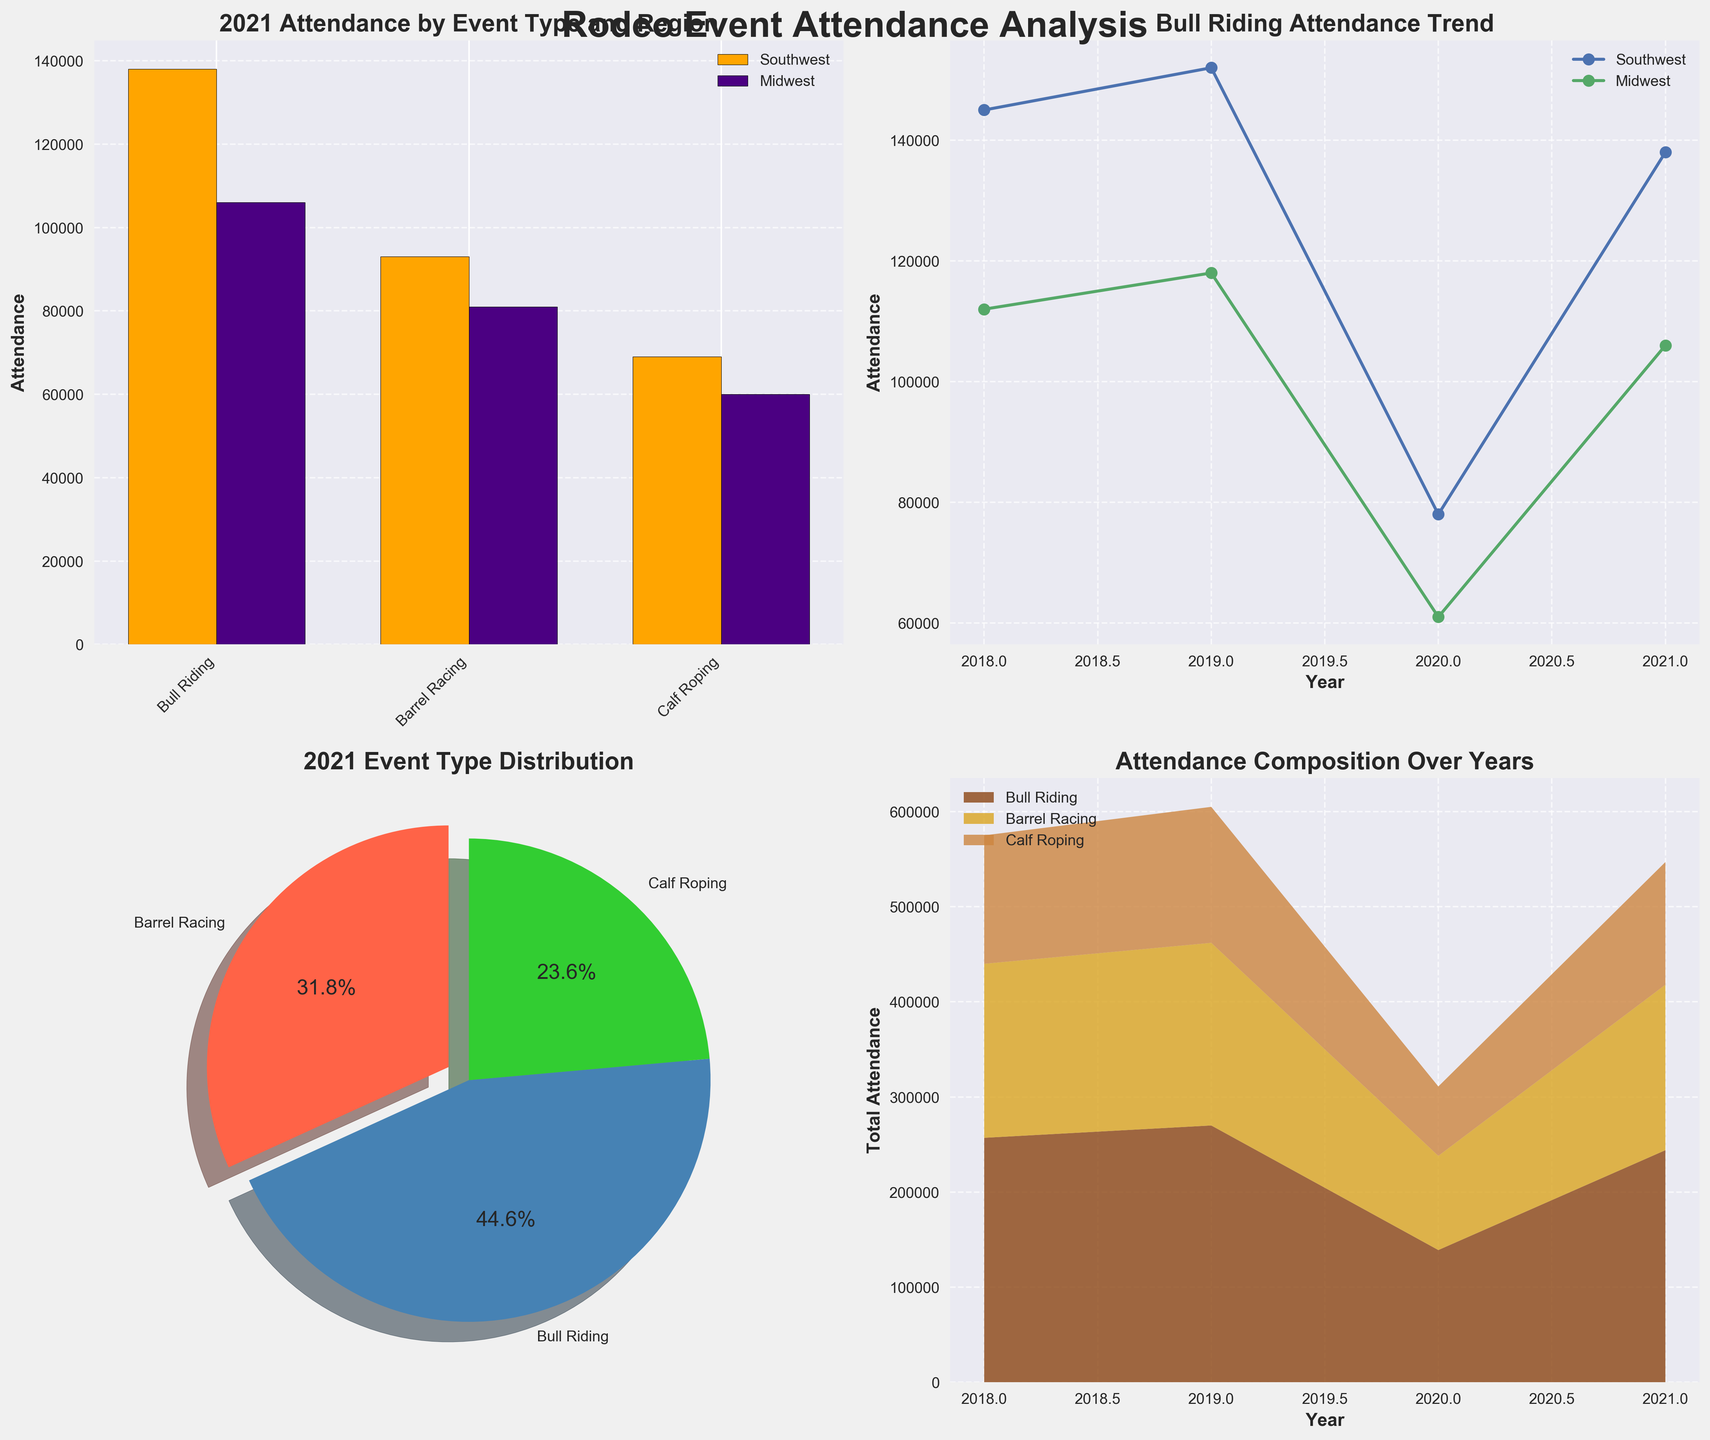What is the title of the subplot at the top left? The title of the subplot at the top left is written above it.
Answer: 2021 Attendance by Event Type and Region Which region had higher attendance for Barrel Racing in 2021? In the top-left bar chart subplot, the bar representing Barrel Racing for the Southwest region is higher compared to the Midwest region.
Answer: Southwest What was the overall trend in Bull Riding attendance from 2018 to 2021? In the line plot subplot at the top right, for both regions, the lines show an increase from 2018 to 2019, a sharp drop in 2020, and a partial recovery by 2021.
Answer: Increasing, then decreasing sharply in 2020, and partially recovering in 2021 Which event had the largest attendance distribution in 2021? The pie chart in the bottom left shows the percentage distribution, and the slice with the highest percentage is Bull Riding.
Answer: Bull Riding How did total attendance for Calf Roping change from 2018 to 2021? In the bottom-right area chart, the color representing Calf Roping shows a decrease from 2018 to 2020 and then a slight increase in 2021.
Answer: Decreased overall Which event type showed the most significant decrease in attendance in 2020? By examining the line plot for Bull Riding and comparing it to attendance values from previous years shown in the bar chart, Bull Riding shows the steepest decline in 2020.
Answer: Bull Riding How does the attendance for Barrel Racing in the Southwest in 2021 compare with 2019? Referring to the top-left bar chart, the bar for Southwest in 2021 is slightly shorter than that of 2019 for Barrel Racing.
Answer: Slightly lower in 2021 What percentage of the 2021 attendance is made up of Barrel Racing? In the bottom-left pie chart, the segment labeled "Barrel Racing" shows the percentage. It is 34.7%.
Answer: 34.7% What is the combined attendance for Bull Riding and Calf Roping in the Midwest for 2021? From the top-left bar chart, add the attendance values for Bull Riding (106,000) and Calf Roping (60,000).
Answer: 166,000 Which event type has the thickest section in the stacked area chart? By looking at the bottom-right stacked area chart, the color associated with Bull Riding has the thickest section overall.
Answer: Bull Riding 